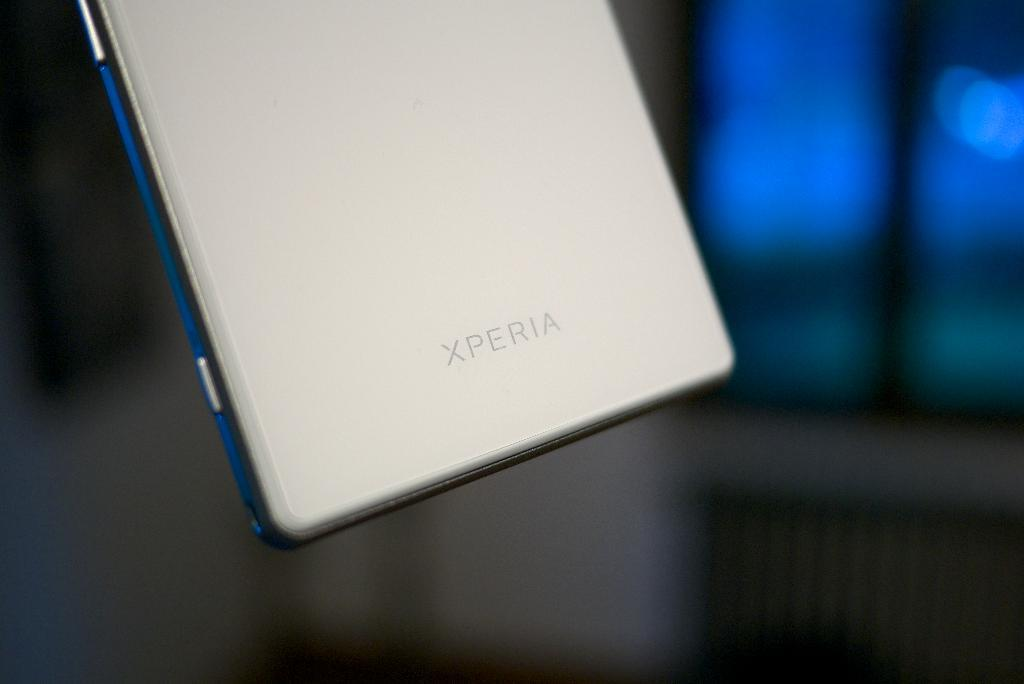<image>
Provide a brief description of the given image. An Xperia product appears to be hovering above a surface. 